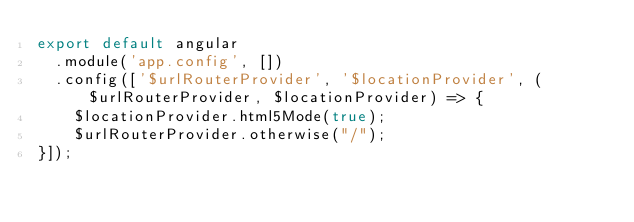<code> <loc_0><loc_0><loc_500><loc_500><_JavaScript_>export default angular
  .module('app.config', [])
  .config(['$urlRouterProvider', '$locationProvider', ($urlRouterProvider, $locationProvider) => {
    $locationProvider.html5Mode(true);
    $urlRouterProvider.otherwise("/");
}]);
</code> 